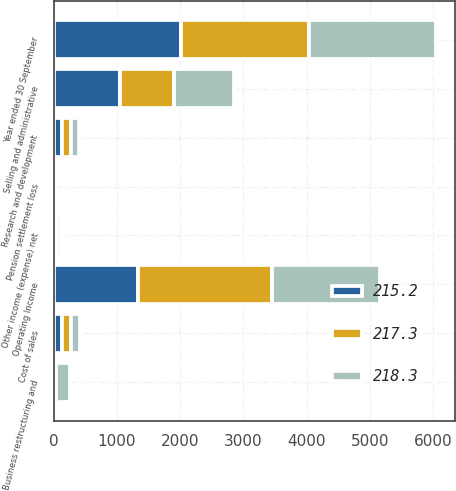Convert chart. <chart><loc_0><loc_0><loc_500><loc_500><stacked_bar_chart><ecel><fcel>Year ended 30 September<fcel>Cost of sales<fcel>Selling and administrative<fcel>Research and development<fcel>Business restructuring and<fcel>Pension settlement loss<fcel>Other income (expense) net<fcel>Operating Income<nl><fcel>217.3<fcel>2016<fcel>139.8<fcel>849.3<fcel>132<fcel>33.9<fcel>6.4<fcel>58.1<fcel>2106<nl><fcel>218.3<fcel>2015<fcel>139.8<fcel>939.3<fcel>137.1<fcel>207.7<fcel>21.2<fcel>47.3<fcel>1708.3<nl><fcel>215.2<fcel>2014<fcel>139.8<fcel>1054.7<fcel>139.8<fcel>12.7<fcel>5.5<fcel>52.8<fcel>1339.1<nl></chart> 